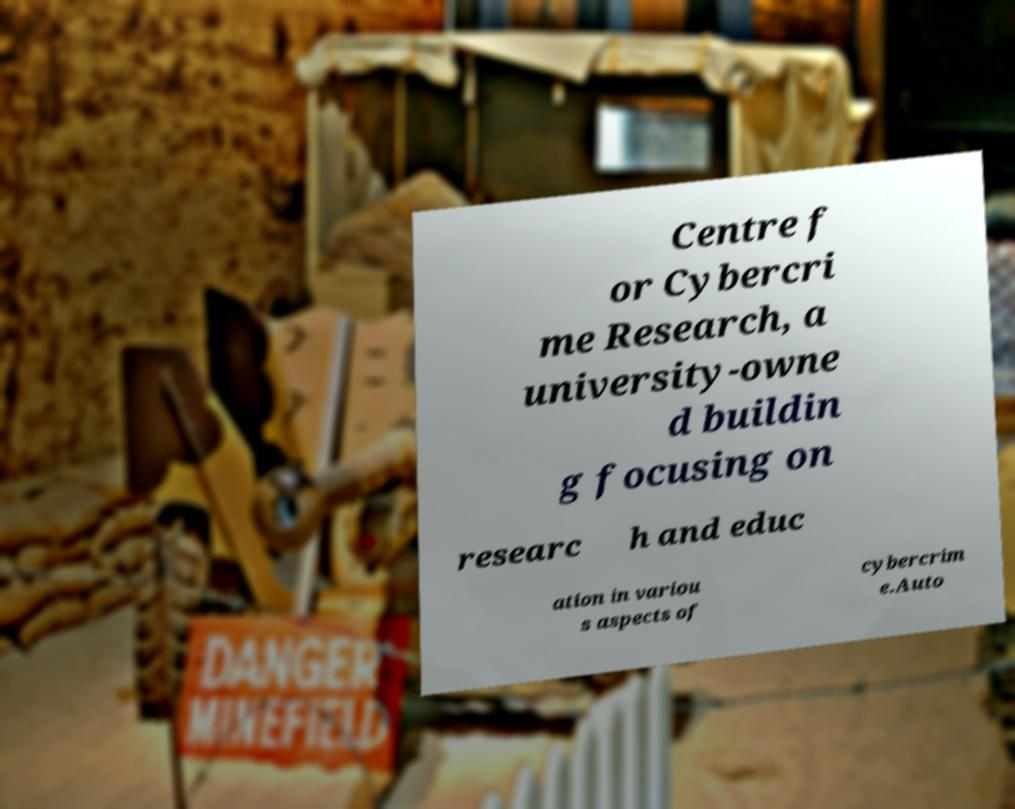Please identify and transcribe the text found in this image. Centre f or Cybercri me Research, a university-owne d buildin g focusing on researc h and educ ation in variou s aspects of cybercrim e.Auto 